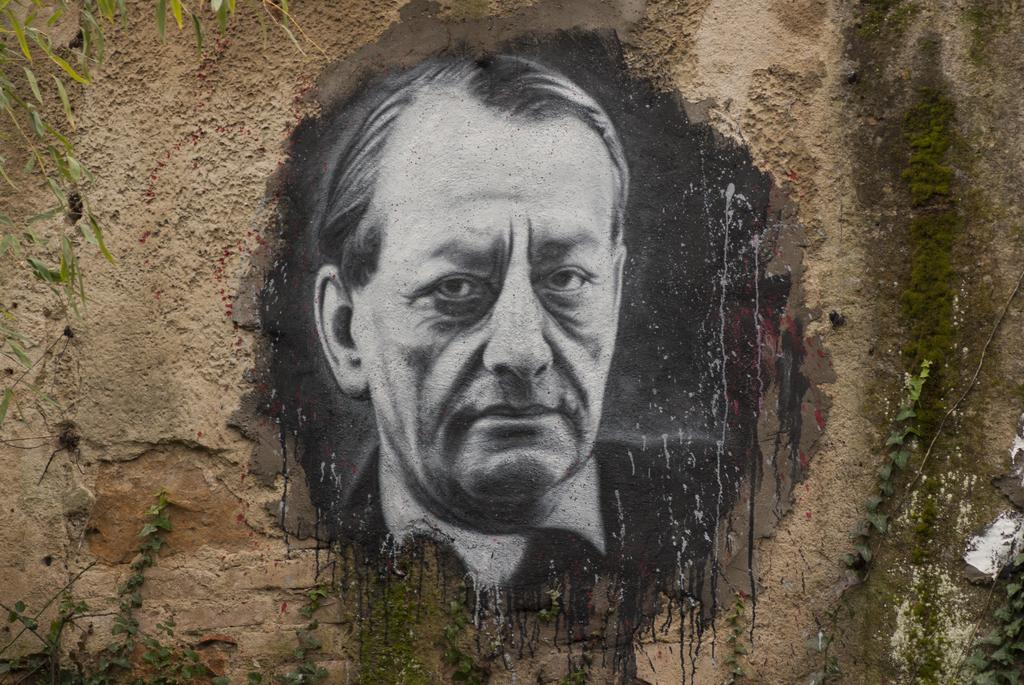What is present on the wall in the image? There is a depiction of a man on the wall. Can you describe the surroundings of the wall in the image? There are planets visible near the wall. What type of ice can be seen melting on the man's face in the image? There is no ice present on the man's face in the image. How long has the man been sleeping in the image? The image does not provide any information about the man's sleep or lack thereof. 